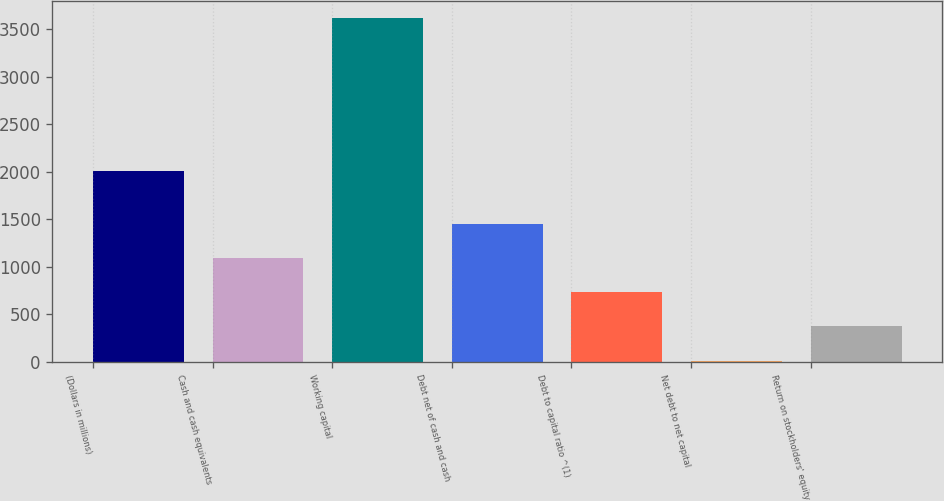Convert chart. <chart><loc_0><loc_0><loc_500><loc_500><bar_chart><fcel>(Dollars in millions)<fcel>Cash and cash equivalents<fcel>Working capital<fcel>Debt net of cash and cash<fcel>Debt to capital ratio ^(1)<fcel>Net debt to net capital<fcel>Return on stockholders' equity<nl><fcel>2004<fcel>1093.97<fcel>3616<fcel>1454.26<fcel>733.68<fcel>13.1<fcel>373.39<nl></chart> 